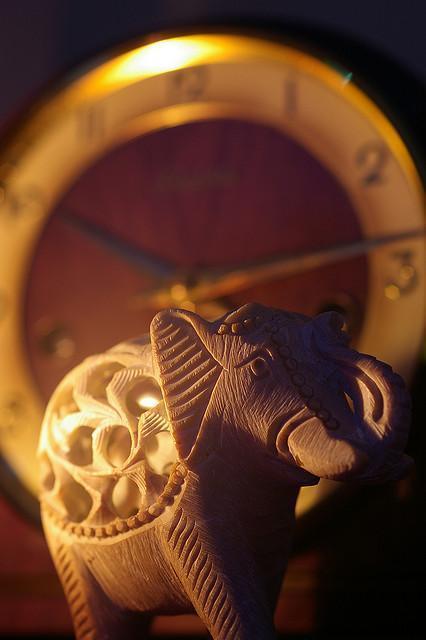How many clocks are there?
Give a very brief answer. 1. How many people are watching the skier go down the hill?
Give a very brief answer. 0. 